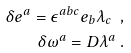Convert formula to latex. <formula><loc_0><loc_0><loc_500><loc_500>\delta e ^ { a } = \epsilon ^ { a b c } e _ { b } \lambda _ { c } \ , \\ \delta \omega ^ { a } = D \lambda ^ { a } \ .</formula> 